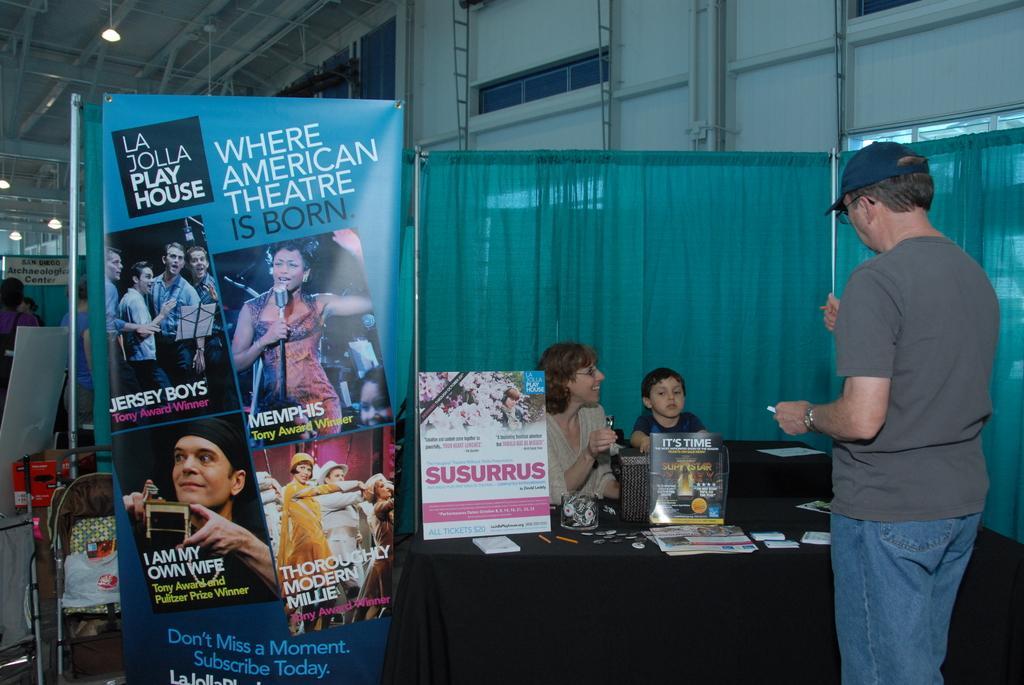Can you describe this image briefly? At the top we can see lights. Here we can see boards. We can see a boy and a woman near to a table and on the table we can see papers and other objects. Here we can see a man wearing a cap, spectacles and standing. These are curtains. In the background we can see people. 